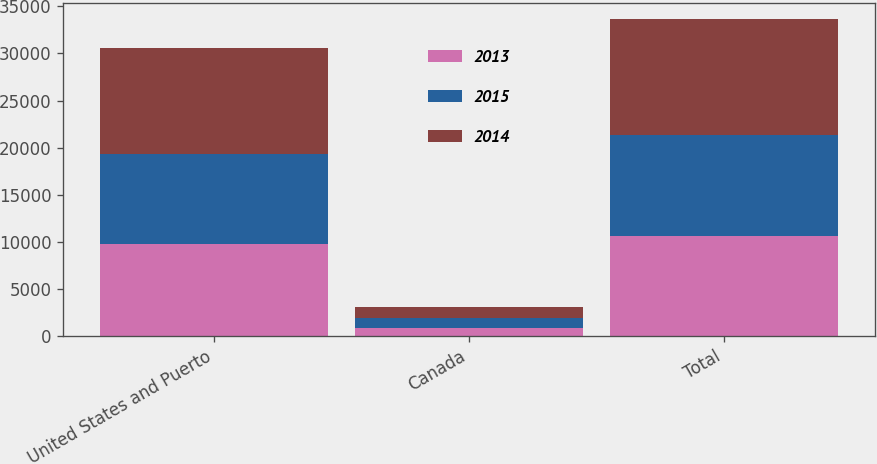Convert chart to OTSL. <chart><loc_0><loc_0><loc_500><loc_500><stacked_bar_chart><ecel><fcel>United States and Puerto<fcel>Canada<fcel>Total<nl><fcel>2013<fcel>9778<fcel>887<fcel>10665<nl><fcel>2015<fcel>9586<fcel>1071<fcel>10657<nl><fcel>2014<fcel>11198<fcel>1146<fcel>12344<nl></chart> 